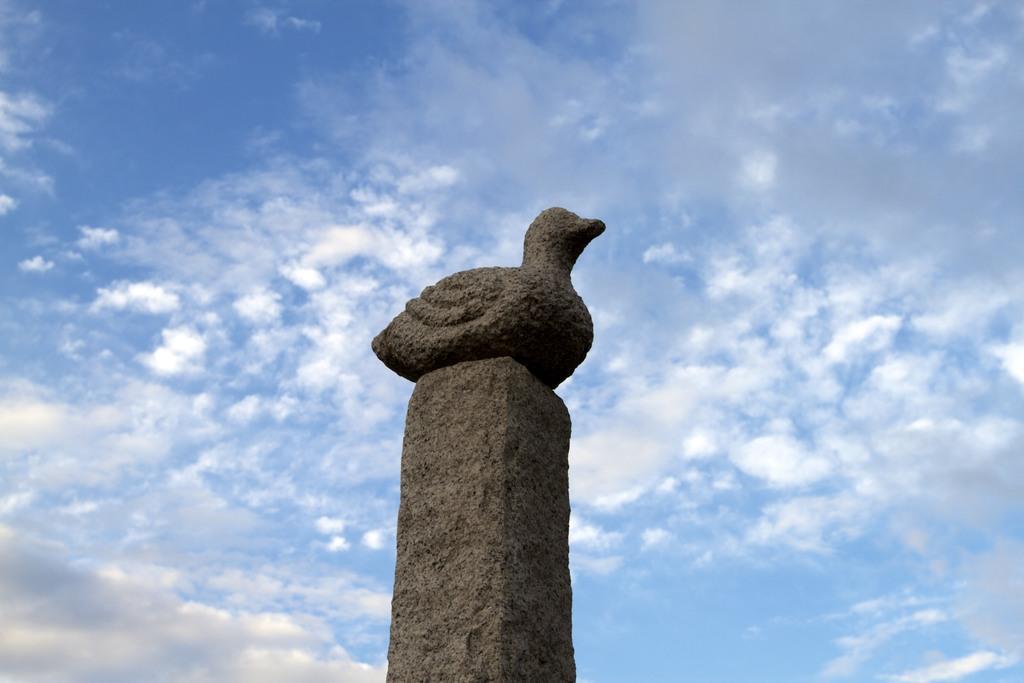Can you describe this image briefly? In the middle of this image, there is a statue of a bird on a pole. In the background, there are clouds in the blue sky. 